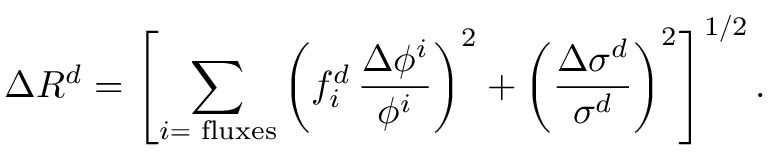<formula> <loc_0><loc_0><loc_500><loc_500>\Delta R ^ { d } = \left [ \sum _ { i = { f l u x e s } } \left ( f _ { i } ^ { d } \, \frac { \Delta \phi ^ { i } } { \phi ^ { i } } \right ) ^ { 2 } + \left ( \frac { \Delta \sigma ^ { d } } { \sigma ^ { d } } \right ) ^ { 2 } \right ] ^ { 1 / 2 } .</formula> 